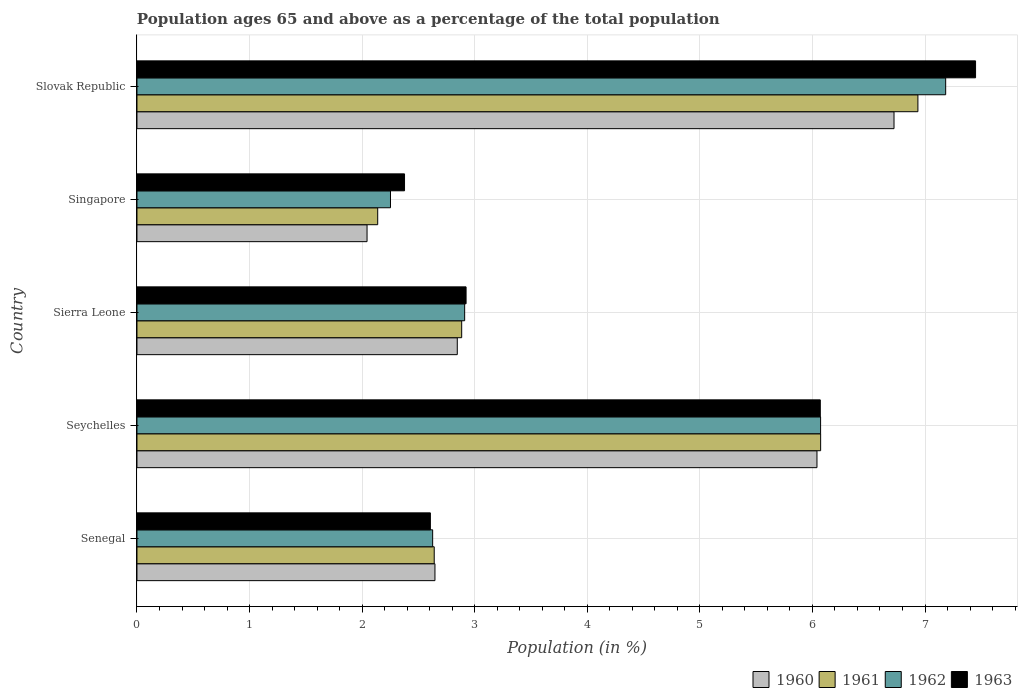How many different coloured bars are there?
Offer a terse response. 4. How many groups of bars are there?
Offer a very short reply. 5. Are the number of bars per tick equal to the number of legend labels?
Make the answer very short. Yes. How many bars are there on the 4th tick from the bottom?
Your response must be concise. 4. What is the label of the 2nd group of bars from the top?
Your answer should be compact. Singapore. In how many cases, is the number of bars for a given country not equal to the number of legend labels?
Your answer should be very brief. 0. What is the percentage of the population ages 65 and above in 1960 in Senegal?
Keep it short and to the point. 2.65. Across all countries, what is the maximum percentage of the population ages 65 and above in 1961?
Keep it short and to the point. 6.94. Across all countries, what is the minimum percentage of the population ages 65 and above in 1960?
Your answer should be compact. 2.04. In which country was the percentage of the population ages 65 and above in 1961 maximum?
Make the answer very short. Slovak Republic. In which country was the percentage of the population ages 65 and above in 1961 minimum?
Your answer should be very brief. Singapore. What is the total percentage of the population ages 65 and above in 1961 in the graph?
Ensure brevity in your answer.  20.67. What is the difference between the percentage of the population ages 65 and above in 1962 in Sierra Leone and that in Slovak Republic?
Provide a short and direct response. -4.27. What is the difference between the percentage of the population ages 65 and above in 1962 in Sierra Leone and the percentage of the population ages 65 and above in 1961 in Senegal?
Provide a succinct answer. 0.27. What is the average percentage of the population ages 65 and above in 1963 per country?
Keep it short and to the point. 4.29. What is the difference between the percentage of the population ages 65 and above in 1962 and percentage of the population ages 65 and above in 1961 in Slovak Republic?
Your answer should be very brief. 0.25. What is the ratio of the percentage of the population ages 65 and above in 1960 in Seychelles to that in Sierra Leone?
Offer a terse response. 2.12. What is the difference between the highest and the second highest percentage of the population ages 65 and above in 1961?
Ensure brevity in your answer.  0.86. What is the difference between the highest and the lowest percentage of the population ages 65 and above in 1963?
Your response must be concise. 5.07. In how many countries, is the percentage of the population ages 65 and above in 1960 greater than the average percentage of the population ages 65 and above in 1960 taken over all countries?
Offer a terse response. 2. Is the sum of the percentage of the population ages 65 and above in 1961 in Sierra Leone and Slovak Republic greater than the maximum percentage of the population ages 65 and above in 1960 across all countries?
Provide a succinct answer. Yes. Is it the case that in every country, the sum of the percentage of the population ages 65 and above in 1960 and percentage of the population ages 65 and above in 1961 is greater than the sum of percentage of the population ages 65 and above in 1963 and percentage of the population ages 65 and above in 1962?
Keep it short and to the point. No. What does the 3rd bar from the top in Sierra Leone represents?
Make the answer very short. 1961. Is it the case that in every country, the sum of the percentage of the population ages 65 and above in 1962 and percentage of the population ages 65 and above in 1961 is greater than the percentage of the population ages 65 and above in 1963?
Provide a succinct answer. Yes. How many bars are there?
Keep it short and to the point. 20. Does the graph contain grids?
Make the answer very short. Yes. Where does the legend appear in the graph?
Your answer should be very brief. Bottom right. How many legend labels are there?
Keep it short and to the point. 4. How are the legend labels stacked?
Make the answer very short. Horizontal. What is the title of the graph?
Ensure brevity in your answer.  Population ages 65 and above as a percentage of the total population. Does "1967" appear as one of the legend labels in the graph?
Your answer should be compact. No. What is the label or title of the X-axis?
Offer a terse response. Population (in %). What is the Population (in %) of 1960 in Senegal?
Ensure brevity in your answer.  2.65. What is the Population (in %) in 1961 in Senegal?
Offer a very short reply. 2.64. What is the Population (in %) of 1962 in Senegal?
Make the answer very short. 2.63. What is the Population (in %) in 1963 in Senegal?
Provide a succinct answer. 2.61. What is the Population (in %) in 1960 in Seychelles?
Ensure brevity in your answer.  6.04. What is the Population (in %) of 1961 in Seychelles?
Ensure brevity in your answer.  6.07. What is the Population (in %) of 1962 in Seychelles?
Make the answer very short. 6.07. What is the Population (in %) in 1963 in Seychelles?
Give a very brief answer. 6.07. What is the Population (in %) of 1960 in Sierra Leone?
Ensure brevity in your answer.  2.85. What is the Population (in %) in 1961 in Sierra Leone?
Provide a short and direct response. 2.88. What is the Population (in %) of 1962 in Sierra Leone?
Keep it short and to the point. 2.91. What is the Population (in %) of 1963 in Sierra Leone?
Your answer should be very brief. 2.92. What is the Population (in %) of 1960 in Singapore?
Your answer should be compact. 2.04. What is the Population (in %) of 1961 in Singapore?
Keep it short and to the point. 2.14. What is the Population (in %) of 1962 in Singapore?
Keep it short and to the point. 2.25. What is the Population (in %) of 1963 in Singapore?
Keep it short and to the point. 2.38. What is the Population (in %) of 1960 in Slovak Republic?
Your answer should be compact. 6.72. What is the Population (in %) in 1961 in Slovak Republic?
Your response must be concise. 6.94. What is the Population (in %) of 1962 in Slovak Republic?
Your response must be concise. 7.18. What is the Population (in %) in 1963 in Slovak Republic?
Offer a terse response. 7.45. Across all countries, what is the maximum Population (in %) of 1960?
Provide a short and direct response. 6.72. Across all countries, what is the maximum Population (in %) in 1961?
Your answer should be very brief. 6.94. Across all countries, what is the maximum Population (in %) of 1962?
Offer a terse response. 7.18. Across all countries, what is the maximum Population (in %) in 1963?
Provide a short and direct response. 7.45. Across all countries, what is the minimum Population (in %) in 1960?
Your answer should be compact. 2.04. Across all countries, what is the minimum Population (in %) of 1961?
Ensure brevity in your answer.  2.14. Across all countries, what is the minimum Population (in %) in 1962?
Give a very brief answer. 2.25. Across all countries, what is the minimum Population (in %) of 1963?
Ensure brevity in your answer.  2.38. What is the total Population (in %) in 1960 in the graph?
Your response must be concise. 20.3. What is the total Population (in %) in 1961 in the graph?
Your response must be concise. 20.67. What is the total Population (in %) in 1962 in the graph?
Ensure brevity in your answer.  21.05. What is the total Population (in %) of 1963 in the graph?
Ensure brevity in your answer.  21.43. What is the difference between the Population (in %) in 1960 in Senegal and that in Seychelles?
Offer a very short reply. -3.39. What is the difference between the Population (in %) of 1961 in Senegal and that in Seychelles?
Your answer should be compact. -3.43. What is the difference between the Population (in %) of 1962 in Senegal and that in Seychelles?
Your response must be concise. -3.45. What is the difference between the Population (in %) in 1963 in Senegal and that in Seychelles?
Give a very brief answer. -3.46. What is the difference between the Population (in %) of 1960 in Senegal and that in Sierra Leone?
Ensure brevity in your answer.  -0.2. What is the difference between the Population (in %) of 1961 in Senegal and that in Sierra Leone?
Provide a short and direct response. -0.24. What is the difference between the Population (in %) in 1962 in Senegal and that in Sierra Leone?
Provide a succinct answer. -0.28. What is the difference between the Population (in %) in 1963 in Senegal and that in Sierra Leone?
Offer a very short reply. -0.32. What is the difference between the Population (in %) in 1960 in Senegal and that in Singapore?
Make the answer very short. 0.6. What is the difference between the Population (in %) of 1961 in Senegal and that in Singapore?
Ensure brevity in your answer.  0.5. What is the difference between the Population (in %) of 1962 in Senegal and that in Singapore?
Your answer should be very brief. 0.37. What is the difference between the Population (in %) in 1963 in Senegal and that in Singapore?
Keep it short and to the point. 0.23. What is the difference between the Population (in %) in 1960 in Senegal and that in Slovak Republic?
Provide a short and direct response. -4.08. What is the difference between the Population (in %) of 1961 in Senegal and that in Slovak Republic?
Your response must be concise. -4.3. What is the difference between the Population (in %) of 1962 in Senegal and that in Slovak Republic?
Your answer should be compact. -4.56. What is the difference between the Population (in %) in 1963 in Senegal and that in Slovak Republic?
Keep it short and to the point. -4.84. What is the difference between the Population (in %) in 1960 in Seychelles and that in Sierra Leone?
Your answer should be very brief. 3.19. What is the difference between the Population (in %) in 1961 in Seychelles and that in Sierra Leone?
Give a very brief answer. 3.19. What is the difference between the Population (in %) of 1962 in Seychelles and that in Sierra Leone?
Your answer should be very brief. 3.16. What is the difference between the Population (in %) in 1963 in Seychelles and that in Sierra Leone?
Provide a short and direct response. 3.15. What is the difference between the Population (in %) in 1960 in Seychelles and that in Singapore?
Your answer should be compact. 4. What is the difference between the Population (in %) of 1961 in Seychelles and that in Singapore?
Offer a terse response. 3.93. What is the difference between the Population (in %) in 1962 in Seychelles and that in Singapore?
Make the answer very short. 3.82. What is the difference between the Population (in %) of 1963 in Seychelles and that in Singapore?
Ensure brevity in your answer.  3.69. What is the difference between the Population (in %) in 1960 in Seychelles and that in Slovak Republic?
Offer a terse response. -0.68. What is the difference between the Population (in %) in 1961 in Seychelles and that in Slovak Republic?
Your answer should be compact. -0.86. What is the difference between the Population (in %) in 1962 in Seychelles and that in Slovak Republic?
Provide a succinct answer. -1.11. What is the difference between the Population (in %) in 1963 in Seychelles and that in Slovak Republic?
Your answer should be compact. -1.38. What is the difference between the Population (in %) in 1960 in Sierra Leone and that in Singapore?
Ensure brevity in your answer.  0.8. What is the difference between the Population (in %) of 1961 in Sierra Leone and that in Singapore?
Give a very brief answer. 0.75. What is the difference between the Population (in %) of 1962 in Sierra Leone and that in Singapore?
Your answer should be very brief. 0.66. What is the difference between the Population (in %) in 1963 in Sierra Leone and that in Singapore?
Provide a short and direct response. 0.55. What is the difference between the Population (in %) of 1960 in Sierra Leone and that in Slovak Republic?
Your answer should be compact. -3.88. What is the difference between the Population (in %) in 1961 in Sierra Leone and that in Slovak Republic?
Your response must be concise. -4.05. What is the difference between the Population (in %) of 1962 in Sierra Leone and that in Slovak Republic?
Keep it short and to the point. -4.27. What is the difference between the Population (in %) of 1963 in Sierra Leone and that in Slovak Republic?
Your response must be concise. -4.53. What is the difference between the Population (in %) of 1960 in Singapore and that in Slovak Republic?
Keep it short and to the point. -4.68. What is the difference between the Population (in %) of 1961 in Singapore and that in Slovak Republic?
Ensure brevity in your answer.  -4.8. What is the difference between the Population (in %) of 1962 in Singapore and that in Slovak Republic?
Your response must be concise. -4.93. What is the difference between the Population (in %) in 1963 in Singapore and that in Slovak Republic?
Ensure brevity in your answer.  -5.07. What is the difference between the Population (in %) in 1960 in Senegal and the Population (in %) in 1961 in Seychelles?
Make the answer very short. -3.43. What is the difference between the Population (in %) of 1960 in Senegal and the Population (in %) of 1962 in Seychelles?
Provide a short and direct response. -3.43. What is the difference between the Population (in %) of 1960 in Senegal and the Population (in %) of 1963 in Seychelles?
Your answer should be compact. -3.42. What is the difference between the Population (in %) in 1961 in Senegal and the Population (in %) in 1962 in Seychelles?
Ensure brevity in your answer.  -3.43. What is the difference between the Population (in %) in 1961 in Senegal and the Population (in %) in 1963 in Seychelles?
Make the answer very short. -3.43. What is the difference between the Population (in %) of 1962 in Senegal and the Population (in %) of 1963 in Seychelles?
Give a very brief answer. -3.44. What is the difference between the Population (in %) of 1960 in Senegal and the Population (in %) of 1961 in Sierra Leone?
Ensure brevity in your answer.  -0.24. What is the difference between the Population (in %) in 1960 in Senegal and the Population (in %) in 1962 in Sierra Leone?
Your response must be concise. -0.26. What is the difference between the Population (in %) in 1960 in Senegal and the Population (in %) in 1963 in Sierra Leone?
Keep it short and to the point. -0.28. What is the difference between the Population (in %) in 1961 in Senegal and the Population (in %) in 1962 in Sierra Leone?
Keep it short and to the point. -0.27. What is the difference between the Population (in %) of 1961 in Senegal and the Population (in %) of 1963 in Sierra Leone?
Give a very brief answer. -0.28. What is the difference between the Population (in %) of 1962 in Senegal and the Population (in %) of 1963 in Sierra Leone?
Make the answer very short. -0.3. What is the difference between the Population (in %) of 1960 in Senegal and the Population (in %) of 1961 in Singapore?
Provide a short and direct response. 0.51. What is the difference between the Population (in %) of 1960 in Senegal and the Population (in %) of 1962 in Singapore?
Ensure brevity in your answer.  0.4. What is the difference between the Population (in %) of 1960 in Senegal and the Population (in %) of 1963 in Singapore?
Offer a very short reply. 0.27. What is the difference between the Population (in %) of 1961 in Senegal and the Population (in %) of 1962 in Singapore?
Keep it short and to the point. 0.39. What is the difference between the Population (in %) in 1961 in Senegal and the Population (in %) in 1963 in Singapore?
Your answer should be very brief. 0.26. What is the difference between the Population (in %) of 1962 in Senegal and the Population (in %) of 1963 in Singapore?
Offer a very short reply. 0.25. What is the difference between the Population (in %) in 1960 in Senegal and the Population (in %) in 1961 in Slovak Republic?
Your response must be concise. -4.29. What is the difference between the Population (in %) in 1960 in Senegal and the Population (in %) in 1962 in Slovak Republic?
Your answer should be very brief. -4.54. What is the difference between the Population (in %) of 1960 in Senegal and the Population (in %) of 1963 in Slovak Republic?
Provide a short and direct response. -4.8. What is the difference between the Population (in %) in 1961 in Senegal and the Population (in %) in 1962 in Slovak Republic?
Provide a succinct answer. -4.54. What is the difference between the Population (in %) in 1961 in Senegal and the Population (in %) in 1963 in Slovak Republic?
Make the answer very short. -4.81. What is the difference between the Population (in %) of 1962 in Senegal and the Population (in %) of 1963 in Slovak Republic?
Give a very brief answer. -4.82. What is the difference between the Population (in %) of 1960 in Seychelles and the Population (in %) of 1961 in Sierra Leone?
Ensure brevity in your answer.  3.16. What is the difference between the Population (in %) of 1960 in Seychelles and the Population (in %) of 1962 in Sierra Leone?
Keep it short and to the point. 3.13. What is the difference between the Population (in %) in 1960 in Seychelles and the Population (in %) in 1963 in Sierra Leone?
Make the answer very short. 3.12. What is the difference between the Population (in %) of 1961 in Seychelles and the Population (in %) of 1962 in Sierra Leone?
Keep it short and to the point. 3.16. What is the difference between the Population (in %) in 1961 in Seychelles and the Population (in %) in 1963 in Sierra Leone?
Keep it short and to the point. 3.15. What is the difference between the Population (in %) in 1962 in Seychelles and the Population (in %) in 1963 in Sierra Leone?
Give a very brief answer. 3.15. What is the difference between the Population (in %) of 1960 in Seychelles and the Population (in %) of 1961 in Singapore?
Your response must be concise. 3.9. What is the difference between the Population (in %) of 1960 in Seychelles and the Population (in %) of 1962 in Singapore?
Offer a very short reply. 3.79. What is the difference between the Population (in %) of 1960 in Seychelles and the Population (in %) of 1963 in Singapore?
Your response must be concise. 3.66. What is the difference between the Population (in %) in 1961 in Seychelles and the Population (in %) in 1962 in Singapore?
Offer a terse response. 3.82. What is the difference between the Population (in %) of 1961 in Seychelles and the Population (in %) of 1963 in Singapore?
Keep it short and to the point. 3.7. What is the difference between the Population (in %) in 1962 in Seychelles and the Population (in %) in 1963 in Singapore?
Offer a terse response. 3.7. What is the difference between the Population (in %) in 1960 in Seychelles and the Population (in %) in 1961 in Slovak Republic?
Offer a very short reply. -0.9. What is the difference between the Population (in %) of 1960 in Seychelles and the Population (in %) of 1962 in Slovak Republic?
Ensure brevity in your answer.  -1.14. What is the difference between the Population (in %) in 1960 in Seychelles and the Population (in %) in 1963 in Slovak Republic?
Give a very brief answer. -1.41. What is the difference between the Population (in %) of 1961 in Seychelles and the Population (in %) of 1962 in Slovak Republic?
Offer a very short reply. -1.11. What is the difference between the Population (in %) in 1961 in Seychelles and the Population (in %) in 1963 in Slovak Republic?
Your response must be concise. -1.38. What is the difference between the Population (in %) of 1962 in Seychelles and the Population (in %) of 1963 in Slovak Republic?
Offer a terse response. -1.38. What is the difference between the Population (in %) in 1960 in Sierra Leone and the Population (in %) in 1961 in Singapore?
Your answer should be very brief. 0.71. What is the difference between the Population (in %) in 1960 in Sierra Leone and the Population (in %) in 1962 in Singapore?
Keep it short and to the point. 0.59. What is the difference between the Population (in %) of 1960 in Sierra Leone and the Population (in %) of 1963 in Singapore?
Give a very brief answer. 0.47. What is the difference between the Population (in %) in 1961 in Sierra Leone and the Population (in %) in 1962 in Singapore?
Offer a terse response. 0.63. What is the difference between the Population (in %) of 1961 in Sierra Leone and the Population (in %) of 1963 in Singapore?
Your answer should be compact. 0.51. What is the difference between the Population (in %) of 1962 in Sierra Leone and the Population (in %) of 1963 in Singapore?
Make the answer very short. 0.53. What is the difference between the Population (in %) in 1960 in Sierra Leone and the Population (in %) in 1961 in Slovak Republic?
Your response must be concise. -4.09. What is the difference between the Population (in %) of 1960 in Sierra Leone and the Population (in %) of 1962 in Slovak Republic?
Ensure brevity in your answer.  -4.34. What is the difference between the Population (in %) in 1960 in Sierra Leone and the Population (in %) in 1963 in Slovak Republic?
Provide a succinct answer. -4.6. What is the difference between the Population (in %) in 1961 in Sierra Leone and the Population (in %) in 1962 in Slovak Republic?
Provide a succinct answer. -4.3. What is the difference between the Population (in %) in 1961 in Sierra Leone and the Population (in %) in 1963 in Slovak Republic?
Your response must be concise. -4.56. What is the difference between the Population (in %) in 1962 in Sierra Leone and the Population (in %) in 1963 in Slovak Republic?
Your answer should be compact. -4.54. What is the difference between the Population (in %) of 1960 in Singapore and the Population (in %) of 1961 in Slovak Republic?
Provide a succinct answer. -4.89. What is the difference between the Population (in %) of 1960 in Singapore and the Population (in %) of 1962 in Slovak Republic?
Your answer should be very brief. -5.14. What is the difference between the Population (in %) in 1960 in Singapore and the Population (in %) in 1963 in Slovak Republic?
Your answer should be very brief. -5.41. What is the difference between the Population (in %) in 1961 in Singapore and the Population (in %) in 1962 in Slovak Republic?
Give a very brief answer. -5.05. What is the difference between the Population (in %) of 1961 in Singapore and the Population (in %) of 1963 in Slovak Republic?
Your response must be concise. -5.31. What is the difference between the Population (in %) in 1962 in Singapore and the Population (in %) in 1963 in Slovak Republic?
Your response must be concise. -5.2. What is the average Population (in %) of 1960 per country?
Your answer should be very brief. 4.06. What is the average Population (in %) in 1961 per country?
Offer a very short reply. 4.13. What is the average Population (in %) of 1962 per country?
Offer a terse response. 4.21. What is the average Population (in %) of 1963 per country?
Give a very brief answer. 4.29. What is the difference between the Population (in %) of 1960 and Population (in %) of 1961 in Senegal?
Your response must be concise. 0.01. What is the difference between the Population (in %) of 1960 and Population (in %) of 1962 in Senegal?
Ensure brevity in your answer.  0.02. What is the difference between the Population (in %) in 1960 and Population (in %) in 1963 in Senegal?
Your response must be concise. 0.04. What is the difference between the Population (in %) in 1961 and Population (in %) in 1962 in Senegal?
Ensure brevity in your answer.  0.01. What is the difference between the Population (in %) of 1961 and Population (in %) of 1963 in Senegal?
Your response must be concise. 0.03. What is the difference between the Population (in %) in 1962 and Population (in %) in 1963 in Senegal?
Give a very brief answer. 0.02. What is the difference between the Population (in %) of 1960 and Population (in %) of 1961 in Seychelles?
Offer a terse response. -0.03. What is the difference between the Population (in %) of 1960 and Population (in %) of 1962 in Seychelles?
Your answer should be compact. -0.03. What is the difference between the Population (in %) in 1960 and Population (in %) in 1963 in Seychelles?
Offer a very short reply. -0.03. What is the difference between the Population (in %) of 1961 and Population (in %) of 1962 in Seychelles?
Offer a very short reply. 0. What is the difference between the Population (in %) of 1961 and Population (in %) of 1963 in Seychelles?
Ensure brevity in your answer.  0. What is the difference between the Population (in %) of 1962 and Population (in %) of 1963 in Seychelles?
Your answer should be very brief. 0. What is the difference between the Population (in %) of 1960 and Population (in %) of 1961 in Sierra Leone?
Provide a succinct answer. -0.04. What is the difference between the Population (in %) of 1960 and Population (in %) of 1962 in Sierra Leone?
Offer a terse response. -0.07. What is the difference between the Population (in %) of 1960 and Population (in %) of 1963 in Sierra Leone?
Keep it short and to the point. -0.08. What is the difference between the Population (in %) of 1961 and Population (in %) of 1962 in Sierra Leone?
Your response must be concise. -0.03. What is the difference between the Population (in %) in 1961 and Population (in %) in 1963 in Sierra Leone?
Your answer should be compact. -0.04. What is the difference between the Population (in %) in 1962 and Population (in %) in 1963 in Sierra Leone?
Provide a succinct answer. -0.01. What is the difference between the Population (in %) in 1960 and Population (in %) in 1961 in Singapore?
Provide a succinct answer. -0.09. What is the difference between the Population (in %) in 1960 and Population (in %) in 1962 in Singapore?
Your answer should be compact. -0.21. What is the difference between the Population (in %) of 1960 and Population (in %) of 1963 in Singapore?
Keep it short and to the point. -0.33. What is the difference between the Population (in %) of 1961 and Population (in %) of 1962 in Singapore?
Make the answer very short. -0.11. What is the difference between the Population (in %) in 1961 and Population (in %) in 1963 in Singapore?
Offer a very short reply. -0.24. What is the difference between the Population (in %) of 1962 and Population (in %) of 1963 in Singapore?
Provide a succinct answer. -0.12. What is the difference between the Population (in %) of 1960 and Population (in %) of 1961 in Slovak Republic?
Your response must be concise. -0.21. What is the difference between the Population (in %) of 1960 and Population (in %) of 1962 in Slovak Republic?
Ensure brevity in your answer.  -0.46. What is the difference between the Population (in %) in 1960 and Population (in %) in 1963 in Slovak Republic?
Provide a short and direct response. -0.72. What is the difference between the Population (in %) of 1961 and Population (in %) of 1962 in Slovak Republic?
Offer a terse response. -0.25. What is the difference between the Population (in %) in 1961 and Population (in %) in 1963 in Slovak Republic?
Offer a terse response. -0.51. What is the difference between the Population (in %) of 1962 and Population (in %) of 1963 in Slovak Republic?
Offer a very short reply. -0.27. What is the ratio of the Population (in %) of 1960 in Senegal to that in Seychelles?
Your answer should be compact. 0.44. What is the ratio of the Population (in %) in 1961 in Senegal to that in Seychelles?
Offer a terse response. 0.43. What is the ratio of the Population (in %) of 1962 in Senegal to that in Seychelles?
Make the answer very short. 0.43. What is the ratio of the Population (in %) in 1963 in Senegal to that in Seychelles?
Your answer should be very brief. 0.43. What is the ratio of the Population (in %) in 1960 in Senegal to that in Sierra Leone?
Provide a short and direct response. 0.93. What is the ratio of the Population (in %) of 1961 in Senegal to that in Sierra Leone?
Your response must be concise. 0.92. What is the ratio of the Population (in %) of 1962 in Senegal to that in Sierra Leone?
Give a very brief answer. 0.9. What is the ratio of the Population (in %) of 1963 in Senegal to that in Sierra Leone?
Give a very brief answer. 0.89. What is the ratio of the Population (in %) of 1960 in Senegal to that in Singapore?
Offer a terse response. 1.3. What is the ratio of the Population (in %) in 1961 in Senegal to that in Singapore?
Ensure brevity in your answer.  1.23. What is the ratio of the Population (in %) of 1962 in Senegal to that in Singapore?
Keep it short and to the point. 1.17. What is the ratio of the Population (in %) of 1963 in Senegal to that in Singapore?
Give a very brief answer. 1.1. What is the ratio of the Population (in %) in 1960 in Senegal to that in Slovak Republic?
Keep it short and to the point. 0.39. What is the ratio of the Population (in %) of 1961 in Senegal to that in Slovak Republic?
Your response must be concise. 0.38. What is the ratio of the Population (in %) in 1962 in Senegal to that in Slovak Republic?
Offer a terse response. 0.37. What is the ratio of the Population (in %) in 1963 in Senegal to that in Slovak Republic?
Provide a succinct answer. 0.35. What is the ratio of the Population (in %) of 1960 in Seychelles to that in Sierra Leone?
Keep it short and to the point. 2.12. What is the ratio of the Population (in %) of 1961 in Seychelles to that in Sierra Leone?
Provide a succinct answer. 2.11. What is the ratio of the Population (in %) of 1962 in Seychelles to that in Sierra Leone?
Make the answer very short. 2.09. What is the ratio of the Population (in %) of 1963 in Seychelles to that in Sierra Leone?
Your response must be concise. 2.08. What is the ratio of the Population (in %) of 1960 in Seychelles to that in Singapore?
Keep it short and to the point. 2.96. What is the ratio of the Population (in %) in 1961 in Seychelles to that in Singapore?
Ensure brevity in your answer.  2.84. What is the ratio of the Population (in %) of 1962 in Seychelles to that in Singapore?
Offer a terse response. 2.7. What is the ratio of the Population (in %) in 1963 in Seychelles to that in Singapore?
Give a very brief answer. 2.55. What is the ratio of the Population (in %) in 1960 in Seychelles to that in Slovak Republic?
Ensure brevity in your answer.  0.9. What is the ratio of the Population (in %) of 1961 in Seychelles to that in Slovak Republic?
Keep it short and to the point. 0.88. What is the ratio of the Population (in %) in 1962 in Seychelles to that in Slovak Republic?
Ensure brevity in your answer.  0.85. What is the ratio of the Population (in %) in 1963 in Seychelles to that in Slovak Republic?
Keep it short and to the point. 0.81. What is the ratio of the Population (in %) in 1960 in Sierra Leone to that in Singapore?
Make the answer very short. 1.39. What is the ratio of the Population (in %) of 1961 in Sierra Leone to that in Singapore?
Give a very brief answer. 1.35. What is the ratio of the Population (in %) of 1962 in Sierra Leone to that in Singapore?
Your response must be concise. 1.29. What is the ratio of the Population (in %) in 1963 in Sierra Leone to that in Singapore?
Your response must be concise. 1.23. What is the ratio of the Population (in %) of 1960 in Sierra Leone to that in Slovak Republic?
Make the answer very short. 0.42. What is the ratio of the Population (in %) of 1961 in Sierra Leone to that in Slovak Republic?
Make the answer very short. 0.42. What is the ratio of the Population (in %) of 1962 in Sierra Leone to that in Slovak Republic?
Make the answer very short. 0.41. What is the ratio of the Population (in %) in 1963 in Sierra Leone to that in Slovak Republic?
Your answer should be very brief. 0.39. What is the ratio of the Population (in %) in 1960 in Singapore to that in Slovak Republic?
Ensure brevity in your answer.  0.3. What is the ratio of the Population (in %) in 1961 in Singapore to that in Slovak Republic?
Your response must be concise. 0.31. What is the ratio of the Population (in %) of 1962 in Singapore to that in Slovak Republic?
Give a very brief answer. 0.31. What is the ratio of the Population (in %) of 1963 in Singapore to that in Slovak Republic?
Give a very brief answer. 0.32. What is the difference between the highest and the second highest Population (in %) in 1960?
Provide a short and direct response. 0.68. What is the difference between the highest and the second highest Population (in %) of 1961?
Offer a terse response. 0.86. What is the difference between the highest and the second highest Population (in %) of 1962?
Give a very brief answer. 1.11. What is the difference between the highest and the second highest Population (in %) in 1963?
Your response must be concise. 1.38. What is the difference between the highest and the lowest Population (in %) in 1960?
Make the answer very short. 4.68. What is the difference between the highest and the lowest Population (in %) of 1961?
Provide a short and direct response. 4.8. What is the difference between the highest and the lowest Population (in %) in 1962?
Give a very brief answer. 4.93. What is the difference between the highest and the lowest Population (in %) of 1963?
Your answer should be very brief. 5.07. 